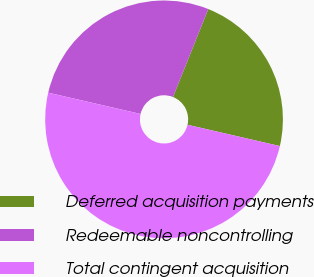<chart> <loc_0><loc_0><loc_500><loc_500><pie_chart><fcel>Deferred acquisition payments<fcel>Redeemable noncontrolling<fcel>Total contingent acquisition<nl><fcel>22.54%<fcel>27.46%<fcel>50.0%<nl></chart> 